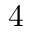Convert formula to latex. <formula><loc_0><loc_0><loc_500><loc_500>4</formula> 